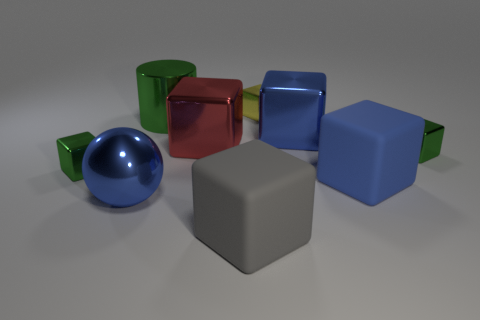Subtract all tiny green cubes. How many cubes are left? 5 Subtract all yellow cubes. How many cubes are left? 6 Subtract all brown balls. How many green blocks are left? 2 Subtract 2 blocks. How many blocks are left? 5 Subtract all spheres. How many objects are left? 8 Add 4 large objects. How many large objects are left? 10 Add 3 large cyan cubes. How many large cyan cubes exist? 3 Subtract 0 cyan cylinders. How many objects are left? 9 Subtract all green balls. Subtract all gray cylinders. How many balls are left? 1 Subtract all cylinders. Subtract all blue blocks. How many objects are left? 6 